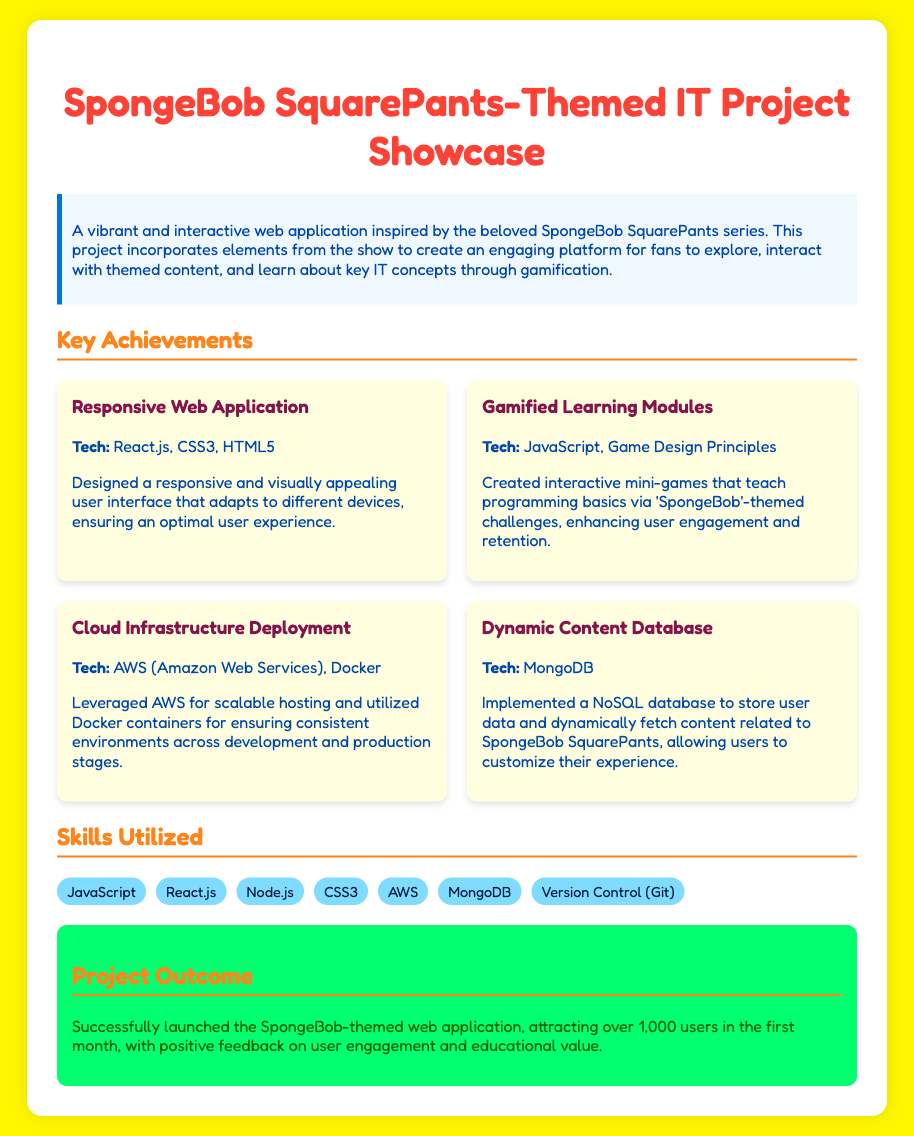What is the project inspiration? The project is inspired by the beloved SpongeBob SquarePants series.
Answer: SpongeBob SquarePants How many users did the project attract in the first month? The document states that the project attracted over 1,000 users in the first month.
Answer: 1,000 users Which technology was used for the responsive web application? The responsive web application was created using React.js, CSS3, and HTML5.
Answer: React.js What type of database was implemented for dynamic content? The document mentions that a NoSQL database was implemented.
Answer: NoSQL What technology was used for cloud infrastructure deployment? The project utilized AWS for scalable hosting.
Answer: AWS Which module enhances user engagement through challenges? The gamified learning modules enhance user engagement through themed challenges.
Answer: Gamified Learning Modules What is the main purpose of the web application? The main purpose is to create an engaging platform for fans to explore themed content and learn IT concepts.
Answer: Engaging platform What are the two main aspects of game development mentioned? The project created interactive mini-games based on game design principles.
Answer: Interactive mini-games How many key achievements are listed in the document? There are four key achievements mentioned in the document.
Answer: Four achievements 